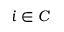<formula> <loc_0><loc_0><loc_500><loc_500>i \in C</formula> 